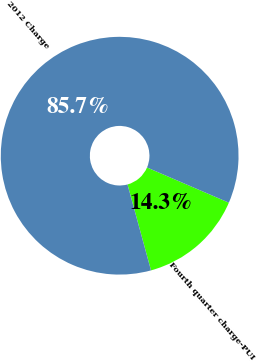<chart> <loc_0><loc_0><loc_500><loc_500><pie_chart><fcel>Fourth quarter charge-PUI<fcel>2012 Charge<nl><fcel>14.29%<fcel>85.71%<nl></chart> 